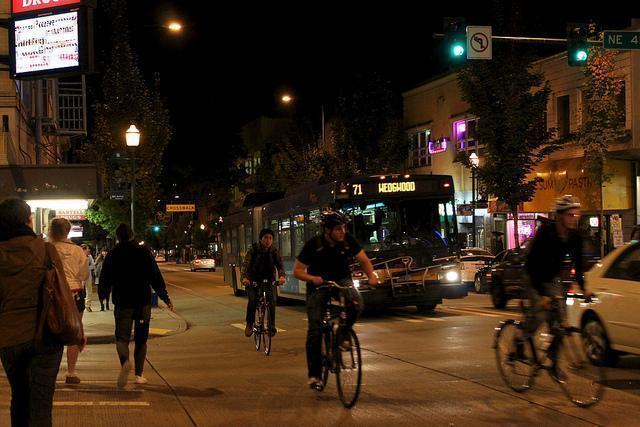What does the sign beside the green light forbid?
Select the correct answer and articulate reasoning with the following format: 'Answer: answer
Rationale: rationale.'
Options: Left turns, right turns, u-turns, going straight. Answer: left turns.
Rationale: The sign beside the green streetlight has a left turn picture with a red cross out mark over it. 